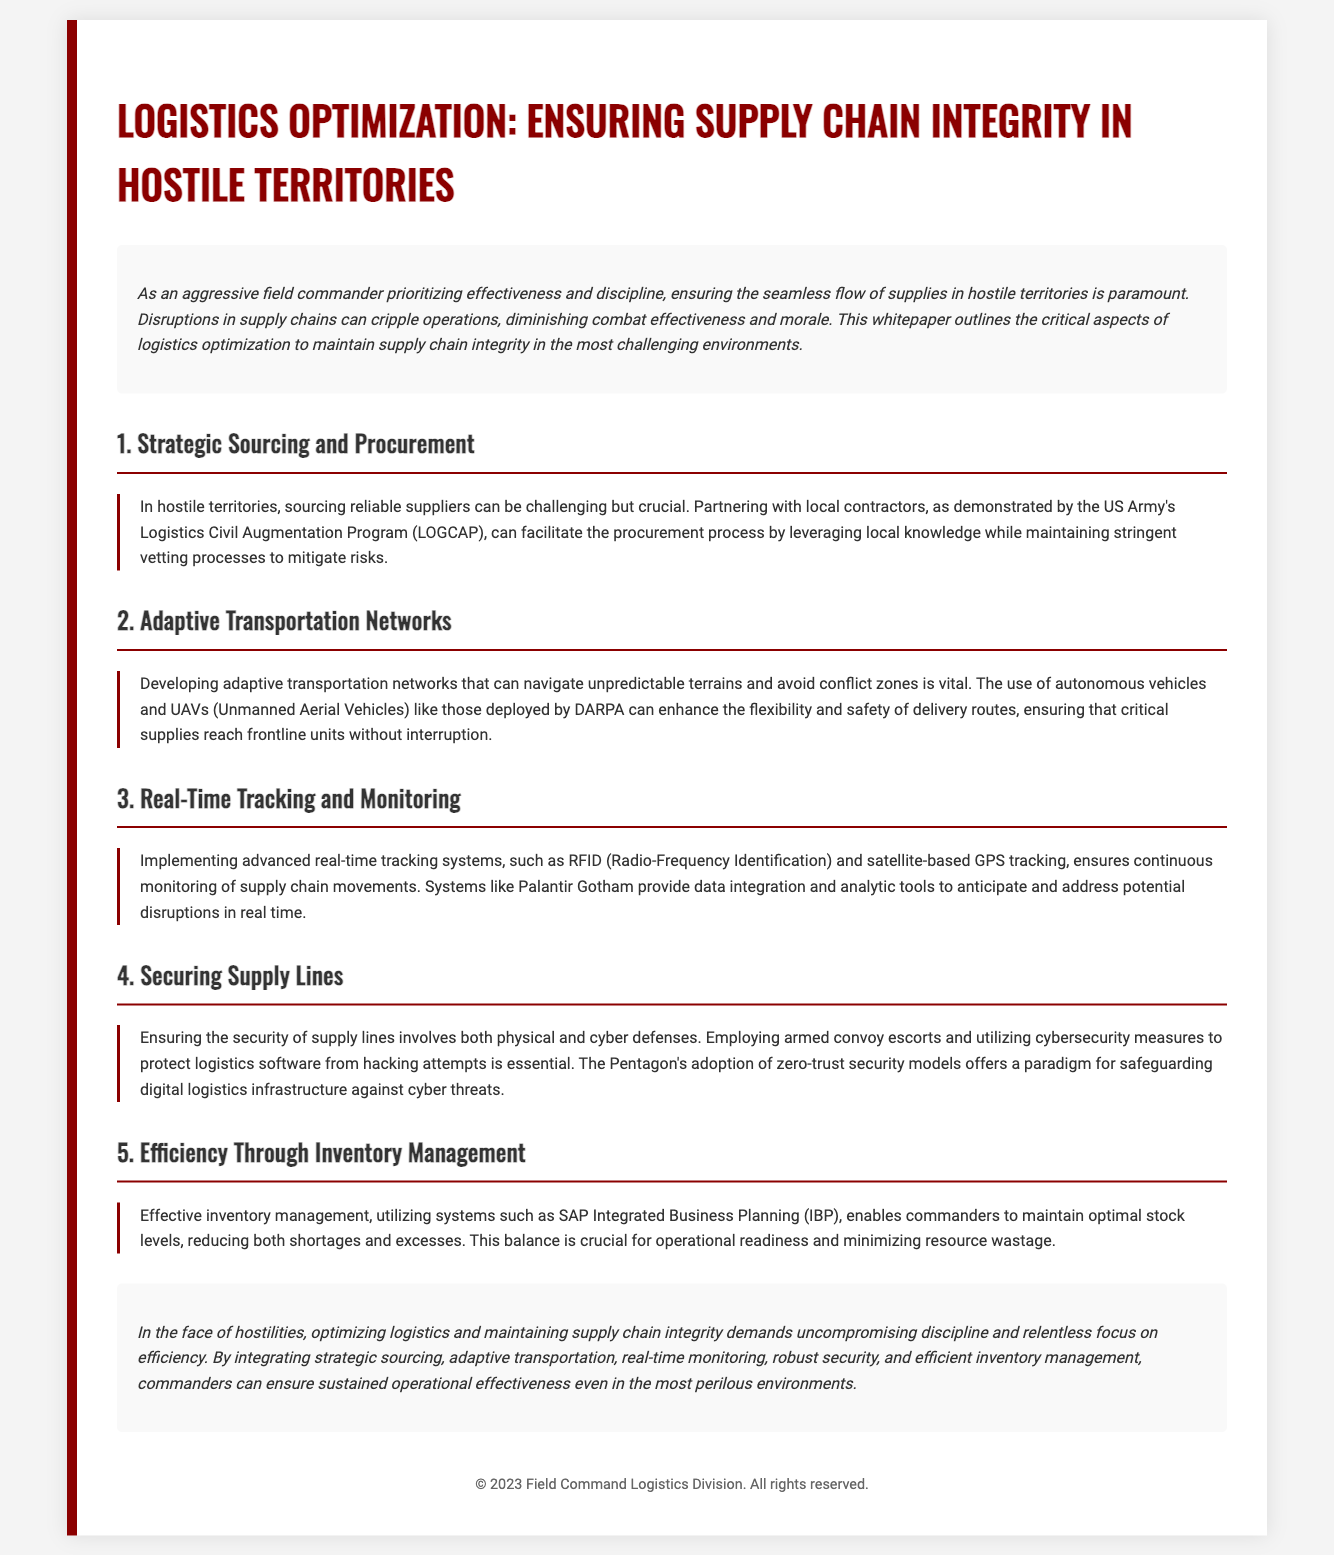what is the title of the whitepaper? The title of the whitepaper is presented prominently at the top of the document, which outlines its focus on logistics.
Answer: Logistics Optimization: Ensuring Supply Chain Integrity in Hostile Territories who is referenced in the section on Strategic Sourcing and Procurement? The document mentions a program that illustrates a method for procuring supplies in hostile environments.
Answer: US Army's Logistics Civil Augmentation Program (LOGCAP) what technology is mentioned for enhancing transportation networks? The document specifies technologies that improve transportation systems in challenging terrains.
Answer: UAVs (Unmanned Aerial Vehicles) which security model is highlighted for protecting logistics infrastructure? A specific security approach used by the Pentagon is emphasized to safeguard logistics against cyber threats.
Answer: zero-trust security models what is the primary benefit of real-time tracking systems mentioned? The tracking systems allow for continuous oversight of supply movements, crucial for proactive management.
Answer: continuous monitoring how does effective inventory management help commanders? The document describes the impact of inventory strategies on operational efficiency and resource use.
Answer: optimal stock levels what is emphasized as essential for ensuring the security of supply lines? The document outlines key measures necessary for safe logistics operations in hostile areas.
Answer: armed convoy escorts what does the conclusion urge for maintaining operational effectiveness? The conclusion stresses a specific approach towards logistics optimization under challenging conditions.
Answer: unwavering discipline 